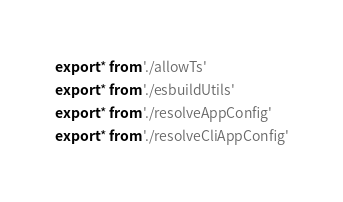Convert code to text. <code><loc_0><loc_0><loc_500><loc_500><_TypeScript_>export * from './allowTs'
export * from './esbuildUtils'
export * from './resolveAppConfig'
export * from './resolveCliAppConfig'
</code> 